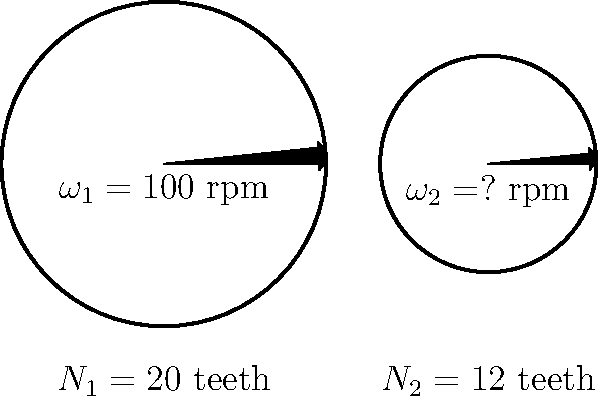Consider a simple gear train consisting of two gears as shown in the figure. The input gear (Gear 1) has 20 teeth and rotates at 100 rpm, while the output gear (Gear 2) has 12 teeth. Determine the rotational speed of Gear 2 and calculate the efficiency of the gear train if the power output is 90% of the power input. Let's approach this problem step-by-step:

1) First, we need to determine the rotational speed of Gear 2. In a simple gear train, the relationship between the number of teeth and angular velocities is:

   $$\frac{N_1}{N_2} = \frac{\omega_2}{\omega_1}$$

   where $N_1$ and $N_2$ are the number of teeth, and $\omega_1$ and $\omega_2$ are the angular velocities of Gear 1 and Gear 2 respectively.

2) We know that $N_1 = 20$, $N_2 = 12$, and $\omega_1 = 100$ rpm. Let's substitute these values:

   $$\frac{20}{12} = \frac{\omega_2}{100}$$

3) Solving for $\omega_2$:

   $$\omega_2 = 100 \cdot \frac{20}{12} = 166.67 \text{ rpm}$$

4) Now, let's consider the efficiency. Efficiency is defined as the ratio of output power to input power:

   $$\text{Efficiency} = \frac{P_{out}}{P_{in}} \cdot 100\%$$

5) We're told that the power output is 90% of the power input. This means:

   $$\text{Efficiency} = \frac{0.9 P_{in}}{P_{in}} \cdot 100\% = 0.9 \cdot 100\% = 90\%$$

Therefore, the rotational speed of Gear 2 is 166.67 rpm, and the efficiency of the gear train is 90%.
Answer: $\omega_2 = 166.67 \text{ rpm}$, Efficiency $= 90\%$ 